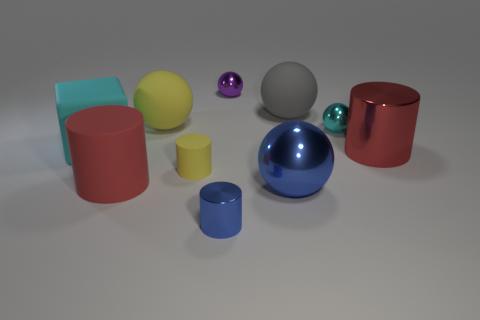Subtract all yellow matte spheres. How many spheres are left? 4 Subtract all purple spheres. How many spheres are left? 4 Subtract all cyan cylinders. Subtract all green balls. How many cylinders are left? 4 Subtract all blocks. How many objects are left? 9 Add 6 yellow cylinders. How many yellow cylinders exist? 7 Subtract 0 red blocks. How many objects are left? 10 Subtract all large cyan matte blocks. Subtract all rubber objects. How many objects are left? 4 Add 7 tiny metal things. How many tiny metal things are left? 10 